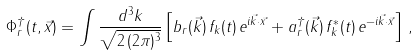Convert formula to latex. <formula><loc_0><loc_0><loc_500><loc_500>\Phi _ { r } ^ { \dagger } ( t , \vec { x } ) = \int \frac { d ^ { 3 } k } { \sqrt { 2 \, ( 2 \pi ) ^ { 3 } } } \left [ b _ { r } ( \vec { k } ) \, f _ { k } ( t ) \, e ^ { i \vec { k } \cdot \vec { x } } + a _ { r } ^ { \dagger } ( \vec { k } ) \, f ^ { * } _ { k } ( t ) \, e ^ { - i \vec { k } \cdot \vec { x } } \right ] \, ,</formula> 